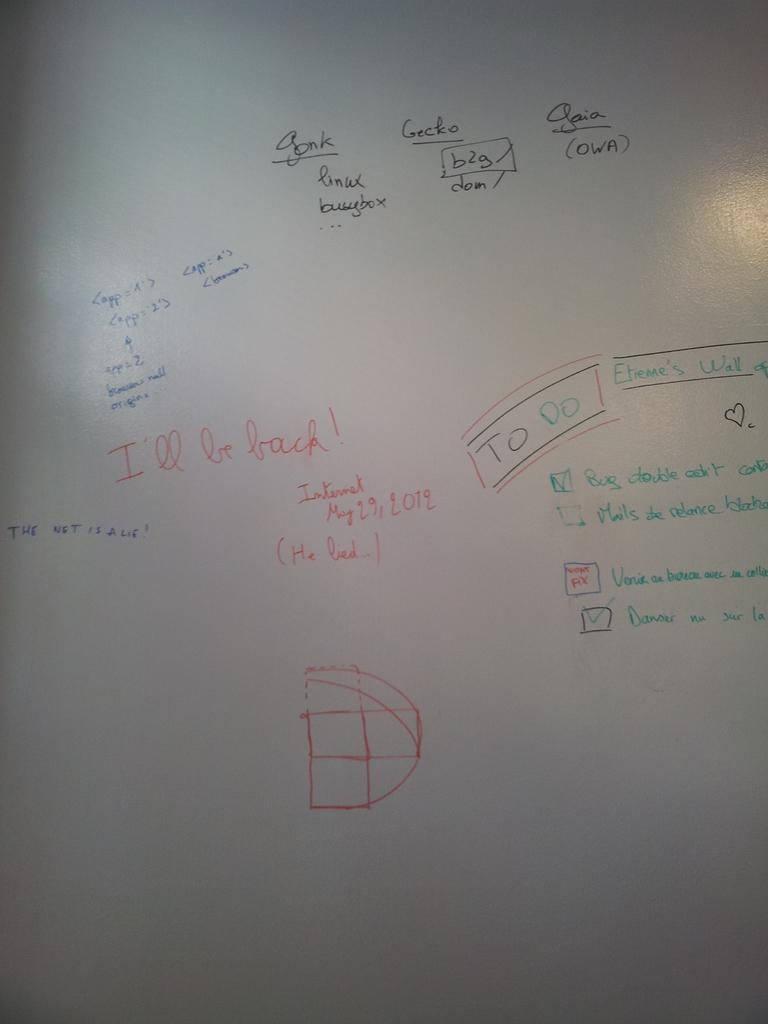<image>
Render a clear and concise summary of the photo. Notes on a white board say that the Internet will be back next to a to-do list. 